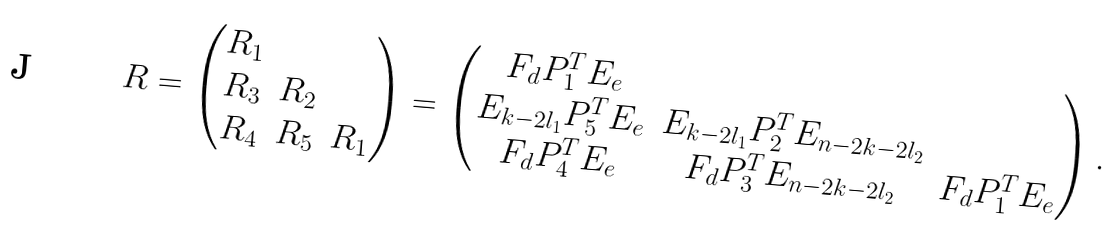<formula> <loc_0><loc_0><loc_500><loc_500>R = \begin{pmatrix} R _ { 1 } \\ R _ { 3 } & R _ { 2 } \\ R _ { 4 } & R _ { 5 } & R _ { 1 } \end{pmatrix} = \begin{pmatrix} F _ { d } P _ { 1 } ^ { T } E _ { e } \\ E _ { k - 2 l _ { 1 } } P _ { 5 } ^ { T } E _ { e } & E _ { k - 2 l _ { 1 } } P _ { 2 } ^ { T } E _ { n - 2 k - 2 l _ { 2 } } \\ F _ { d } P _ { 4 } ^ { T } E _ { e } & F _ { d } P _ { 3 } ^ { T } E _ { n - 2 k - 2 l _ { 2 } } & F _ { d } P _ { 1 } ^ { T } E _ { e } \end{pmatrix} .</formula> 